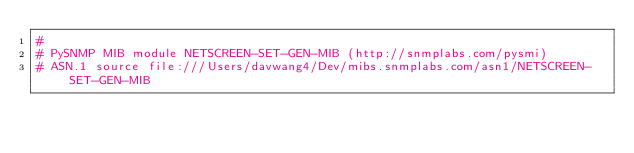<code> <loc_0><loc_0><loc_500><loc_500><_Python_>#
# PySNMP MIB module NETSCREEN-SET-GEN-MIB (http://snmplabs.com/pysmi)
# ASN.1 source file:///Users/davwang4/Dev/mibs.snmplabs.com/asn1/NETSCREEN-SET-GEN-MIB</code> 